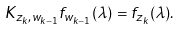Convert formula to latex. <formula><loc_0><loc_0><loc_500><loc_500>K _ { z _ { k } , w _ { k - 1 } } f _ { w _ { k - 1 } } ( \lambda ) = f _ { z _ { k } } ( \lambda ) .</formula> 